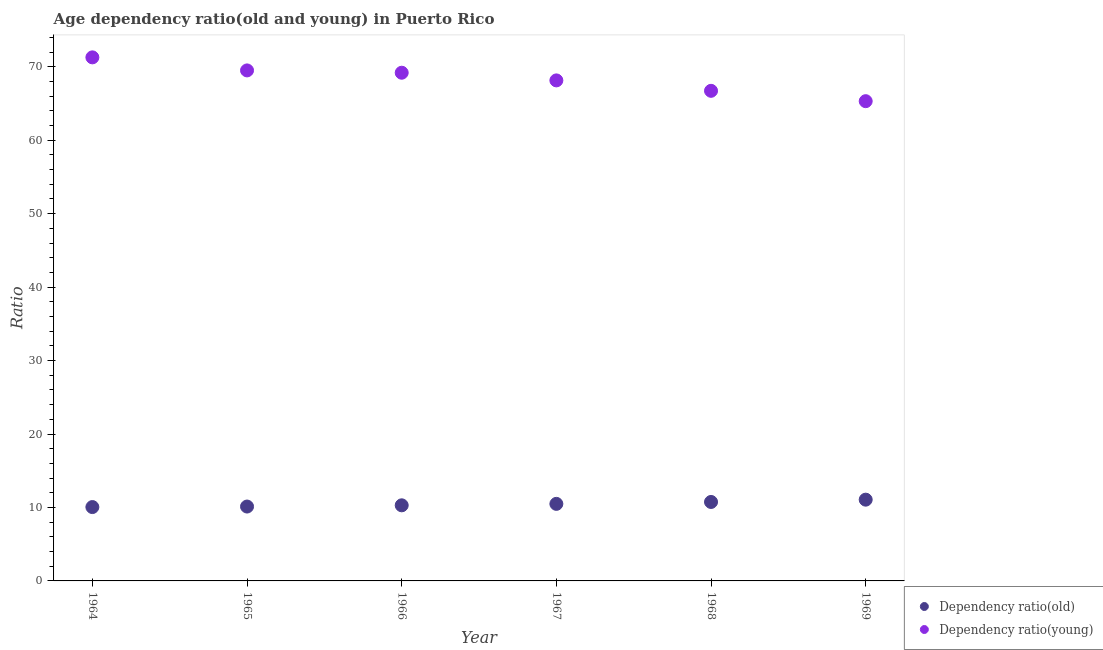What is the age dependency ratio(old) in 1965?
Your response must be concise. 10.13. Across all years, what is the maximum age dependency ratio(young)?
Your answer should be very brief. 71.28. Across all years, what is the minimum age dependency ratio(old)?
Provide a succinct answer. 10.06. In which year was the age dependency ratio(young) maximum?
Offer a very short reply. 1964. In which year was the age dependency ratio(old) minimum?
Your answer should be compact. 1964. What is the total age dependency ratio(old) in the graph?
Give a very brief answer. 62.78. What is the difference between the age dependency ratio(old) in 1964 and that in 1966?
Offer a terse response. -0.24. What is the difference between the age dependency ratio(old) in 1965 and the age dependency ratio(young) in 1967?
Ensure brevity in your answer.  -58.02. What is the average age dependency ratio(old) per year?
Ensure brevity in your answer.  10.46. In the year 1968, what is the difference between the age dependency ratio(young) and age dependency ratio(old)?
Make the answer very short. 55.97. In how many years, is the age dependency ratio(young) greater than 40?
Provide a short and direct response. 6. What is the ratio of the age dependency ratio(young) in 1966 to that in 1967?
Your answer should be very brief. 1.02. Is the age dependency ratio(young) in 1966 less than that in 1969?
Keep it short and to the point. No. Is the difference between the age dependency ratio(young) in 1964 and 1965 greater than the difference between the age dependency ratio(old) in 1964 and 1965?
Keep it short and to the point. Yes. What is the difference between the highest and the second highest age dependency ratio(old)?
Provide a short and direct response. 0.31. What is the difference between the highest and the lowest age dependency ratio(old)?
Your answer should be compact. 1.01. Does the age dependency ratio(old) monotonically increase over the years?
Your response must be concise. Yes. Is the age dependency ratio(young) strictly greater than the age dependency ratio(old) over the years?
Ensure brevity in your answer.  Yes. Is the age dependency ratio(young) strictly less than the age dependency ratio(old) over the years?
Offer a terse response. No. Are the values on the major ticks of Y-axis written in scientific E-notation?
Your response must be concise. No. Does the graph contain grids?
Your answer should be compact. No. What is the title of the graph?
Offer a terse response. Age dependency ratio(old and young) in Puerto Rico. Does "% of GNI" appear as one of the legend labels in the graph?
Make the answer very short. No. What is the label or title of the X-axis?
Keep it short and to the point. Year. What is the label or title of the Y-axis?
Provide a short and direct response. Ratio. What is the Ratio of Dependency ratio(old) in 1964?
Offer a terse response. 10.06. What is the Ratio in Dependency ratio(young) in 1964?
Offer a terse response. 71.28. What is the Ratio in Dependency ratio(old) in 1965?
Your response must be concise. 10.13. What is the Ratio in Dependency ratio(young) in 1965?
Make the answer very short. 69.5. What is the Ratio of Dependency ratio(old) in 1966?
Ensure brevity in your answer.  10.29. What is the Ratio in Dependency ratio(young) in 1966?
Offer a terse response. 69.19. What is the Ratio of Dependency ratio(old) in 1967?
Make the answer very short. 10.49. What is the Ratio of Dependency ratio(young) in 1967?
Your answer should be very brief. 68.14. What is the Ratio in Dependency ratio(old) in 1968?
Give a very brief answer. 10.75. What is the Ratio of Dependency ratio(young) in 1968?
Your response must be concise. 66.72. What is the Ratio in Dependency ratio(old) in 1969?
Give a very brief answer. 11.06. What is the Ratio of Dependency ratio(young) in 1969?
Offer a very short reply. 65.31. Across all years, what is the maximum Ratio of Dependency ratio(old)?
Keep it short and to the point. 11.06. Across all years, what is the maximum Ratio in Dependency ratio(young)?
Give a very brief answer. 71.28. Across all years, what is the minimum Ratio in Dependency ratio(old)?
Your response must be concise. 10.06. Across all years, what is the minimum Ratio of Dependency ratio(young)?
Provide a short and direct response. 65.31. What is the total Ratio of Dependency ratio(old) in the graph?
Provide a short and direct response. 62.78. What is the total Ratio in Dependency ratio(young) in the graph?
Your answer should be very brief. 410.15. What is the difference between the Ratio of Dependency ratio(old) in 1964 and that in 1965?
Your response must be concise. -0.07. What is the difference between the Ratio of Dependency ratio(young) in 1964 and that in 1965?
Provide a succinct answer. 1.78. What is the difference between the Ratio of Dependency ratio(old) in 1964 and that in 1966?
Give a very brief answer. -0.24. What is the difference between the Ratio of Dependency ratio(young) in 1964 and that in 1966?
Offer a very short reply. 2.09. What is the difference between the Ratio of Dependency ratio(old) in 1964 and that in 1967?
Make the answer very short. -0.43. What is the difference between the Ratio of Dependency ratio(young) in 1964 and that in 1967?
Make the answer very short. 3.14. What is the difference between the Ratio of Dependency ratio(old) in 1964 and that in 1968?
Make the answer very short. -0.69. What is the difference between the Ratio in Dependency ratio(young) in 1964 and that in 1968?
Give a very brief answer. 4.56. What is the difference between the Ratio of Dependency ratio(old) in 1964 and that in 1969?
Your answer should be compact. -1.01. What is the difference between the Ratio in Dependency ratio(young) in 1964 and that in 1969?
Your answer should be compact. 5.96. What is the difference between the Ratio of Dependency ratio(old) in 1965 and that in 1966?
Give a very brief answer. -0.17. What is the difference between the Ratio in Dependency ratio(young) in 1965 and that in 1966?
Your response must be concise. 0.31. What is the difference between the Ratio of Dependency ratio(old) in 1965 and that in 1967?
Ensure brevity in your answer.  -0.36. What is the difference between the Ratio of Dependency ratio(young) in 1965 and that in 1967?
Keep it short and to the point. 1.36. What is the difference between the Ratio of Dependency ratio(old) in 1965 and that in 1968?
Give a very brief answer. -0.62. What is the difference between the Ratio of Dependency ratio(young) in 1965 and that in 1968?
Your answer should be very brief. 2.78. What is the difference between the Ratio of Dependency ratio(old) in 1965 and that in 1969?
Provide a succinct answer. -0.94. What is the difference between the Ratio in Dependency ratio(young) in 1965 and that in 1969?
Provide a succinct answer. 4.19. What is the difference between the Ratio in Dependency ratio(old) in 1966 and that in 1967?
Make the answer very short. -0.2. What is the difference between the Ratio of Dependency ratio(young) in 1966 and that in 1967?
Your response must be concise. 1.04. What is the difference between the Ratio of Dependency ratio(old) in 1966 and that in 1968?
Your answer should be very brief. -0.46. What is the difference between the Ratio of Dependency ratio(young) in 1966 and that in 1968?
Your response must be concise. 2.46. What is the difference between the Ratio of Dependency ratio(old) in 1966 and that in 1969?
Offer a terse response. -0.77. What is the difference between the Ratio of Dependency ratio(young) in 1966 and that in 1969?
Provide a short and direct response. 3.87. What is the difference between the Ratio in Dependency ratio(old) in 1967 and that in 1968?
Ensure brevity in your answer.  -0.26. What is the difference between the Ratio of Dependency ratio(young) in 1967 and that in 1968?
Provide a short and direct response. 1.42. What is the difference between the Ratio in Dependency ratio(old) in 1967 and that in 1969?
Your answer should be compact. -0.57. What is the difference between the Ratio of Dependency ratio(young) in 1967 and that in 1969?
Offer a terse response. 2.83. What is the difference between the Ratio of Dependency ratio(old) in 1968 and that in 1969?
Your response must be concise. -0.31. What is the difference between the Ratio of Dependency ratio(young) in 1968 and that in 1969?
Offer a terse response. 1.41. What is the difference between the Ratio of Dependency ratio(old) in 1964 and the Ratio of Dependency ratio(young) in 1965?
Provide a succinct answer. -59.45. What is the difference between the Ratio in Dependency ratio(old) in 1964 and the Ratio in Dependency ratio(young) in 1966?
Offer a very short reply. -59.13. What is the difference between the Ratio in Dependency ratio(old) in 1964 and the Ratio in Dependency ratio(young) in 1967?
Provide a succinct answer. -58.09. What is the difference between the Ratio in Dependency ratio(old) in 1964 and the Ratio in Dependency ratio(young) in 1968?
Keep it short and to the point. -56.67. What is the difference between the Ratio of Dependency ratio(old) in 1964 and the Ratio of Dependency ratio(young) in 1969?
Your response must be concise. -55.26. What is the difference between the Ratio in Dependency ratio(old) in 1965 and the Ratio in Dependency ratio(young) in 1966?
Offer a terse response. -59.06. What is the difference between the Ratio of Dependency ratio(old) in 1965 and the Ratio of Dependency ratio(young) in 1967?
Make the answer very short. -58.02. What is the difference between the Ratio in Dependency ratio(old) in 1965 and the Ratio in Dependency ratio(young) in 1968?
Your response must be concise. -56.6. What is the difference between the Ratio of Dependency ratio(old) in 1965 and the Ratio of Dependency ratio(young) in 1969?
Give a very brief answer. -55.19. What is the difference between the Ratio of Dependency ratio(old) in 1966 and the Ratio of Dependency ratio(young) in 1967?
Offer a very short reply. -57.85. What is the difference between the Ratio of Dependency ratio(old) in 1966 and the Ratio of Dependency ratio(young) in 1968?
Keep it short and to the point. -56.43. What is the difference between the Ratio in Dependency ratio(old) in 1966 and the Ratio in Dependency ratio(young) in 1969?
Provide a short and direct response. -55.02. What is the difference between the Ratio in Dependency ratio(old) in 1967 and the Ratio in Dependency ratio(young) in 1968?
Keep it short and to the point. -56.23. What is the difference between the Ratio of Dependency ratio(old) in 1967 and the Ratio of Dependency ratio(young) in 1969?
Your response must be concise. -54.82. What is the difference between the Ratio in Dependency ratio(old) in 1968 and the Ratio in Dependency ratio(young) in 1969?
Offer a very short reply. -54.57. What is the average Ratio of Dependency ratio(old) per year?
Offer a very short reply. 10.46. What is the average Ratio of Dependency ratio(young) per year?
Your answer should be very brief. 68.36. In the year 1964, what is the difference between the Ratio of Dependency ratio(old) and Ratio of Dependency ratio(young)?
Provide a succinct answer. -61.22. In the year 1965, what is the difference between the Ratio in Dependency ratio(old) and Ratio in Dependency ratio(young)?
Make the answer very short. -59.38. In the year 1966, what is the difference between the Ratio of Dependency ratio(old) and Ratio of Dependency ratio(young)?
Your response must be concise. -58.89. In the year 1967, what is the difference between the Ratio in Dependency ratio(old) and Ratio in Dependency ratio(young)?
Provide a short and direct response. -57.65. In the year 1968, what is the difference between the Ratio of Dependency ratio(old) and Ratio of Dependency ratio(young)?
Offer a very short reply. -55.97. In the year 1969, what is the difference between the Ratio in Dependency ratio(old) and Ratio in Dependency ratio(young)?
Your answer should be very brief. -54.25. What is the ratio of the Ratio of Dependency ratio(old) in 1964 to that in 1965?
Provide a short and direct response. 0.99. What is the ratio of the Ratio in Dependency ratio(young) in 1964 to that in 1965?
Give a very brief answer. 1.03. What is the ratio of the Ratio in Dependency ratio(old) in 1964 to that in 1966?
Keep it short and to the point. 0.98. What is the ratio of the Ratio in Dependency ratio(young) in 1964 to that in 1966?
Provide a succinct answer. 1.03. What is the ratio of the Ratio in Dependency ratio(old) in 1964 to that in 1967?
Ensure brevity in your answer.  0.96. What is the ratio of the Ratio of Dependency ratio(young) in 1964 to that in 1967?
Provide a succinct answer. 1.05. What is the ratio of the Ratio of Dependency ratio(old) in 1964 to that in 1968?
Give a very brief answer. 0.94. What is the ratio of the Ratio of Dependency ratio(young) in 1964 to that in 1968?
Offer a very short reply. 1.07. What is the ratio of the Ratio in Dependency ratio(old) in 1964 to that in 1969?
Give a very brief answer. 0.91. What is the ratio of the Ratio in Dependency ratio(young) in 1964 to that in 1969?
Provide a short and direct response. 1.09. What is the ratio of the Ratio of Dependency ratio(old) in 1965 to that in 1966?
Provide a succinct answer. 0.98. What is the ratio of the Ratio in Dependency ratio(young) in 1965 to that in 1966?
Your response must be concise. 1. What is the ratio of the Ratio of Dependency ratio(old) in 1965 to that in 1967?
Provide a succinct answer. 0.97. What is the ratio of the Ratio in Dependency ratio(young) in 1965 to that in 1967?
Provide a short and direct response. 1.02. What is the ratio of the Ratio of Dependency ratio(old) in 1965 to that in 1968?
Your answer should be compact. 0.94. What is the ratio of the Ratio of Dependency ratio(young) in 1965 to that in 1968?
Keep it short and to the point. 1.04. What is the ratio of the Ratio in Dependency ratio(old) in 1965 to that in 1969?
Give a very brief answer. 0.92. What is the ratio of the Ratio in Dependency ratio(young) in 1965 to that in 1969?
Provide a succinct answer. 1.06. What is the ratio of the Ratio of Dependency ratio(old) in 1966 to that in 1967?
Provide a succinct answer. 0.98. What is the ratio of the Ratio of Dependency ratio(young) in 1966 to that in 1967?
Make the answer very short. 1.02. What is the ratio of the Ratio in Dependency ratio(old) in 1966 to that in 1968?
Your answer should be compact. 0.96. What is the ratio of the Ratio of Dependency ratio(young) in 1966 to that in 1968?
Ensure brevity in your answer.  1.04. What is the ratio of the Ratio of Dependency ratio(old) in 1966 to that in 1969?
Ensure brevity in your answer.  0.93. What is the ratio of the Ratio in Dependency ratio(young) in 1966 to that in 1969?
Offer a very short reply. 1.06. What is the ratio of the Ratio in Dependency ratio(old) in 1967 to that in 1968?
Keep it short and to the point. 0.98. What is the ratio of the Ratio in Dependency ratio(young) in 1967 to that in 1968?
Your answer should be very brief. 1.02. What is the ratio of the Ratio of Dependency ratio(old) in 1967 to that in 1969?
Your response must be concise. 0.95. What is the ratio of the Ratio of Dependency ratio(young) in 1967 to that in 1969?
Offer a terse response. 1.04. What is the ratio of the Ratio of Dependency ratio(old) in 1968 to that in 1969?
Offer a very short reply. 0.97. What is the ratio of the Ratio in Dependency ratio(young) in 1968 to that in 1969?
Provide a succinct answer. 1.02. What is the difference between the highest and the second highest Ratio in Dependency ratio(old)?
Your response must be concise. 0.31. What is the difference between the highest and the second highest Ratio in Dependency ratio(young)?
Offer a very short reply. 1.78. What is the difference between the highest and the lowest Ratio in Dependency ratio(old)?
Your answer should be compact. 1.01. What is the difference between the highest and the lowest Ratio of Dependency ratio(young)?
Give a very brief answer. 5.96. 